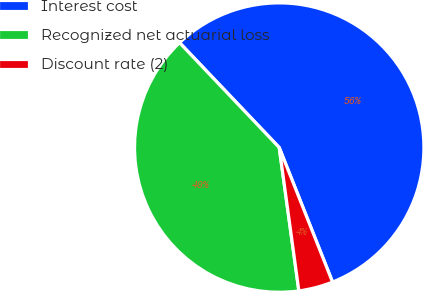Convert chart. <chart><loc_0><loc_0><loc_500><loc_500><pie_chart><fcel>Interest cost<fcel>Recognized net actuarial loss<fcel>Discount rate (2)<nl><fcel>56.09%<fcel>40.07%<fcel>3.84%<nl></chart> 